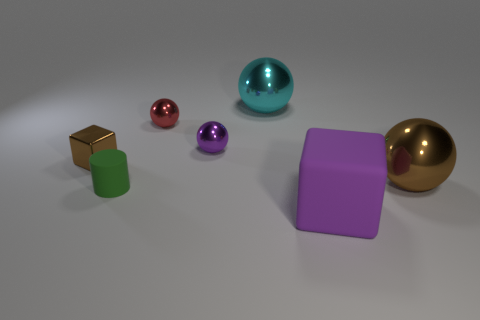Are there any other things that are the same shape as the green object?
Your response must be concise. No. What number of things are either metal things that are to the right of the purple matte block or small purple objects?
Make the answer very short. 2. How many other things are the same color as the tiny matte cylinder?
Ensure brevity in your answer.  0. Is the color of the tiny block the same as the big metallic ball in front of the shiny block?
Provide a succinct answer. Yes. The other thing that is the same shape as the purple matte thing is what color?
Ensure brevity in your answer.  Brown. Are the brown block and the purple thing on the right side of the tiny purple object made of the same material?
Your response must be concise. No. The cylinder has what color?
Offer a very short reply. Green. What color is the large ball that is to the left of the large metallic ball that is in front of the large shiny sphere that is on the left side of the purple matte object?
Offer a very short reply. Cyan. There is a tiny red thing; is it the same shape as the purple thing that is behind the small cylinder?
Offer a very short reply. Yes. What color is the large thing that is both in front of the purple metallic ball and behind the tiny cylinder?
Offer a very short reply. Brown. 